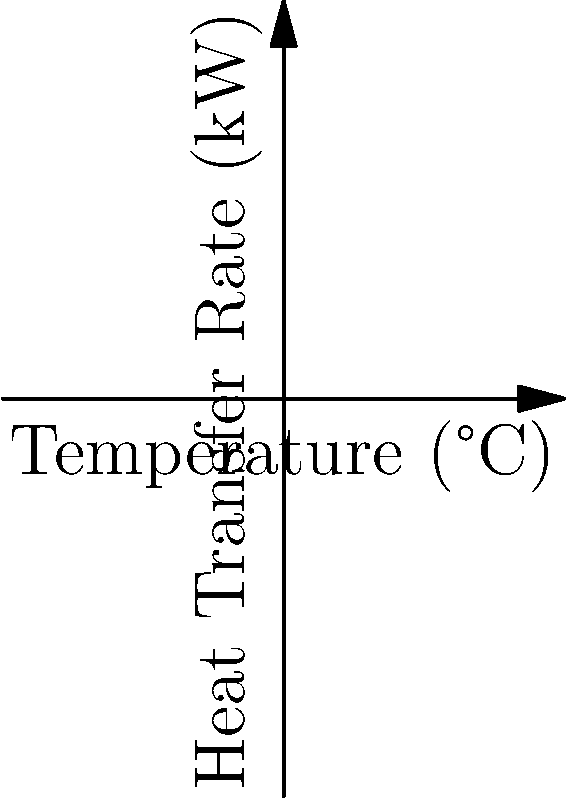In a heat exchanger used for crude oil refining at the Dangote Refinery, hot oil enters at 200°C and exits at 160°C, while cooling water enters at 20°C and exits at 60°C. The specific heat capacity of oil is 2.5 kJ/(kg·°C) and that of water is 4.2 kJ/(kg·°C). If the mass flow rate of oil is 50 kg/s, calculate the efficiency of the heat exchanger. To calculate the efficiency of the heat exchanger, we need to follow these steps:

1. Calculate the actual heat transfer rate:
   $Q_{actual} = m_{oil} \cdot c_{p,oil} \cdot (T_{h,in} - T_{h,out})$
   $Q_{actual} = 50 \text{ kg/s} \cdot 2.5 \text{ kJ/(kg·°C)} \cdot (200°C - 160°C) = 5000 \text{ kW}$

2. Calculate the maximum possible heat transfer rate:
   $Q_{max} = m_{oil} \cdot c_{p,oil} \cdot (T_{h,in} - T_{c,in})$
   $Q_{max} = 50 \text{ kg/s} \cdot 2.5 \text{ kJ/(kg·°C)} \cdot (200°C - 20°C) = 22500 \text{ kW}$

3. Calculate the efficiency:
   $\text{Efficiency} = \frac{Q_{actual}}{Q_{max}} \cdot 100\%$
   $\text{Efficiency} = \frac{5000 \text{ kW}}{22500 \text{ kW}} \cdot 100\% = 22.22\%$

Therefore, the efficiency of the heat exchanger is approximately 22.22%.
Answer: 22.22% 